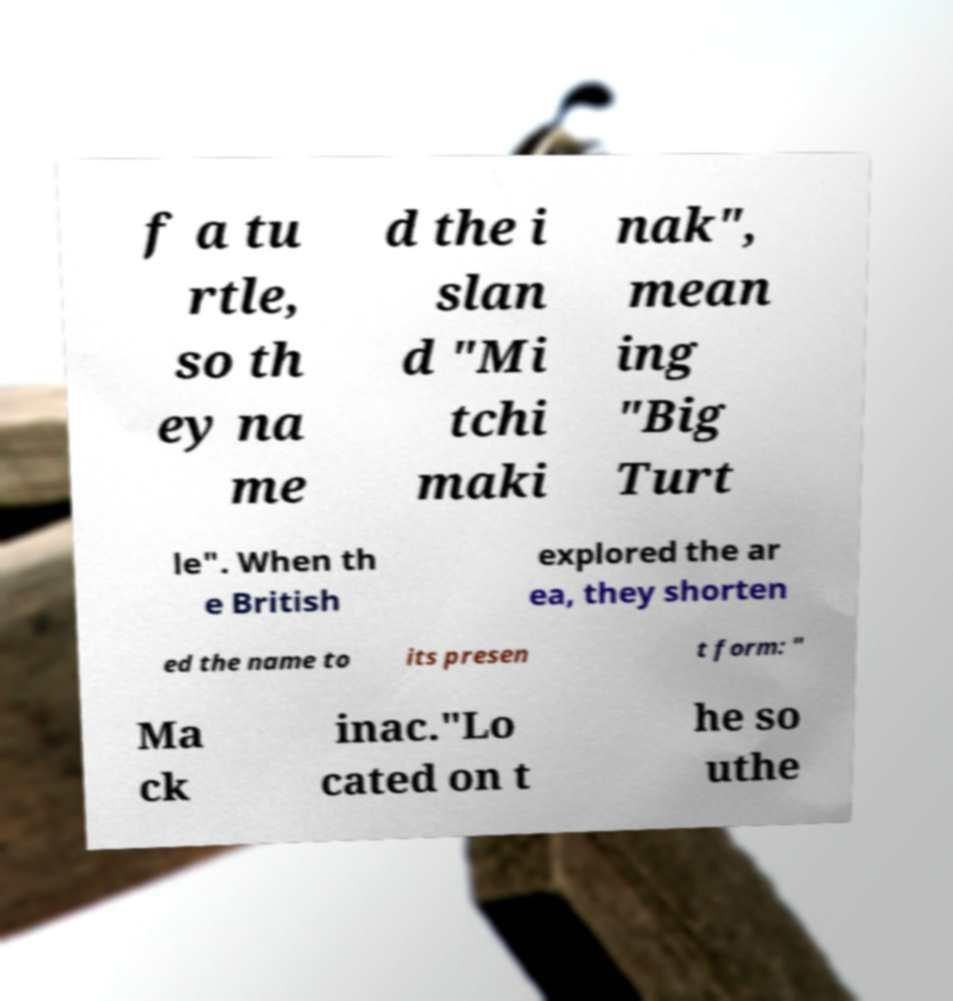Could you extract and type out the text from this image? f a tu rtle, so th ey na me d the i slan d "Mi tchi maki nak", mean ing "Big Turt le". When th e British explored the ar ea, they shorten ed the name to its presen t form: " Ma ck inac."Lo cated on t he so uthe 